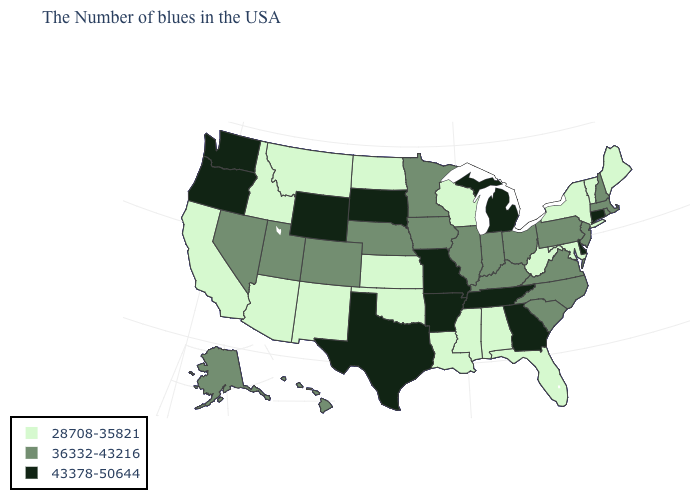Among the states that border Delaware , which have the lowest value?
Answer briefly. Maryland. What is the value of Alabama?
Be succinct. 28708-35821. Name the states that have a value in the range 28708-35821?
Keep it brief. Maine, Vermont, New York, Maryland, West Virginia, Florida, Alabama, Wisconsin, Mississippi, Louisiana, Kansas, Oklahoma, North Dakota, New Mexico, Montana, Arizona, Idaho, California. Does Hawaii have the lowest value in the West?
Concise answer only. No. Name the states that have a value in the range 28708-35821?
Keep it brief. Maine, Vermont, New York, Maryland, West Virginia, Florida, Alabama, Wisconsin, Mississippi, Louisiana, Kansas, Oklahoma, North Dakota, New Mexico, Montana, Arizona, Idaho, California. Does the first symbol in the legend represent the smallest category?
Keep it brief. Yes. Does Indiana have the lowest value in the USA?
Concise answer only. No. What is the value of West Virginia?
Answer briefly. 28708-35821. Does the map have missing data?
Give a very brief answer. No. Does Wyoming have a higher value than New Mexico?
Short answer required. Yes. Does Washington have the highest value in the USA?
Quick response, please. Yes. Which states have the lowest value in the USA?
Answer briefly. Maine, Vermont, New York, Maryland, West Virginia, Florida, Alabama, Wisconsin, Mississippi, Louisiana, Kansas, Oklahoma, North Dakota, New Mexico, Montana, Arizona, Idaho, California. Which states have the lowest value in the USA?
Concise answer only. Maine, Vermont, New York, Maryland, West Virginia, Florida, Alabama, Wisconsin, Mississippi, Louisiana, Kansas, Oklahoma, North Dakota, New Mexico, Montana, Arizona, Idaho, California. Does Alabama have the lowest value in the South?
Concise answer only. Yes. What is the highest value in the South ?
Write a very short answer. 43378-50644. 